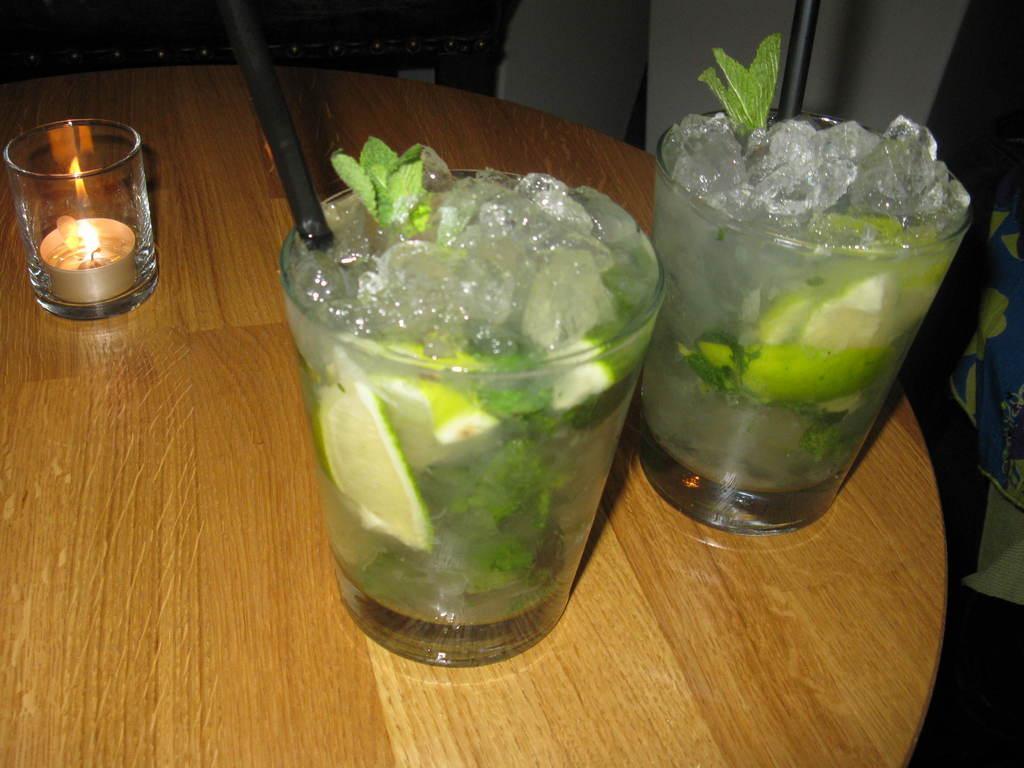Can you describe this image briefly? In this image we can see glasses, straws, candle, ice cubes, leaves, and lemon slices, all those are on the wooden table. 